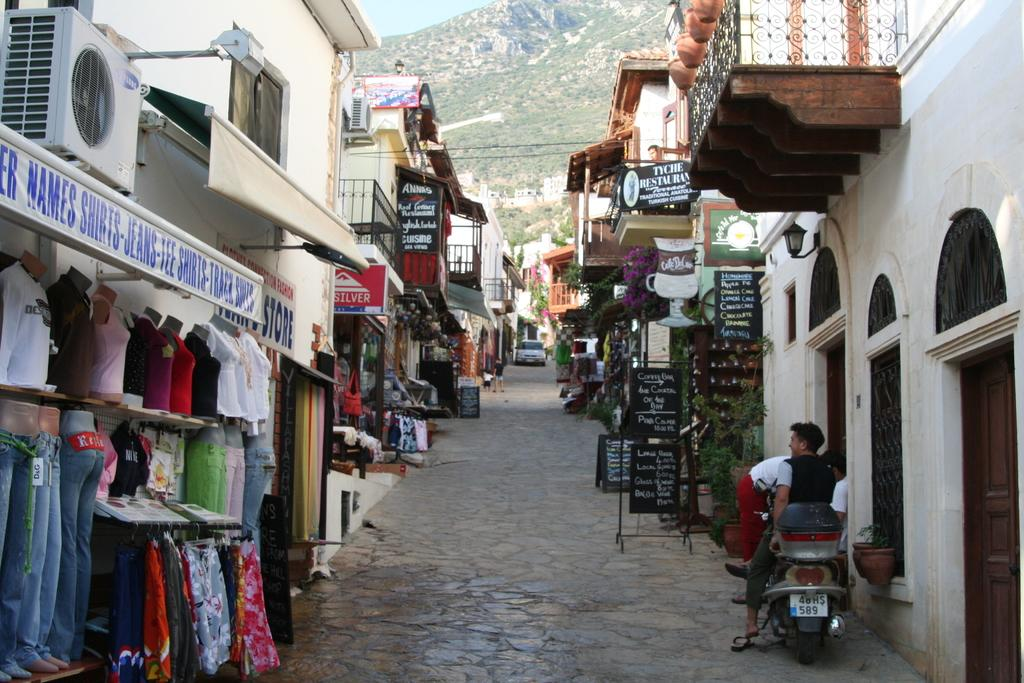Where was the image taken? The image was clicked outside. What can be seen on the left side of the image? There are buildings on the left side of the image. What can be seen on the right side of the image? There are buildings on the right side of the image. What is at the bottom of the image? There is a bike at the bottom of the image. Who is on the bike? A person is sitting on the bike. What is in the middle of the image? There is a car in the middle of the image. How many clocks are hanging on the buildings in the image? There is no information about clocks in the image, so we cannot determine the number of clocks. 